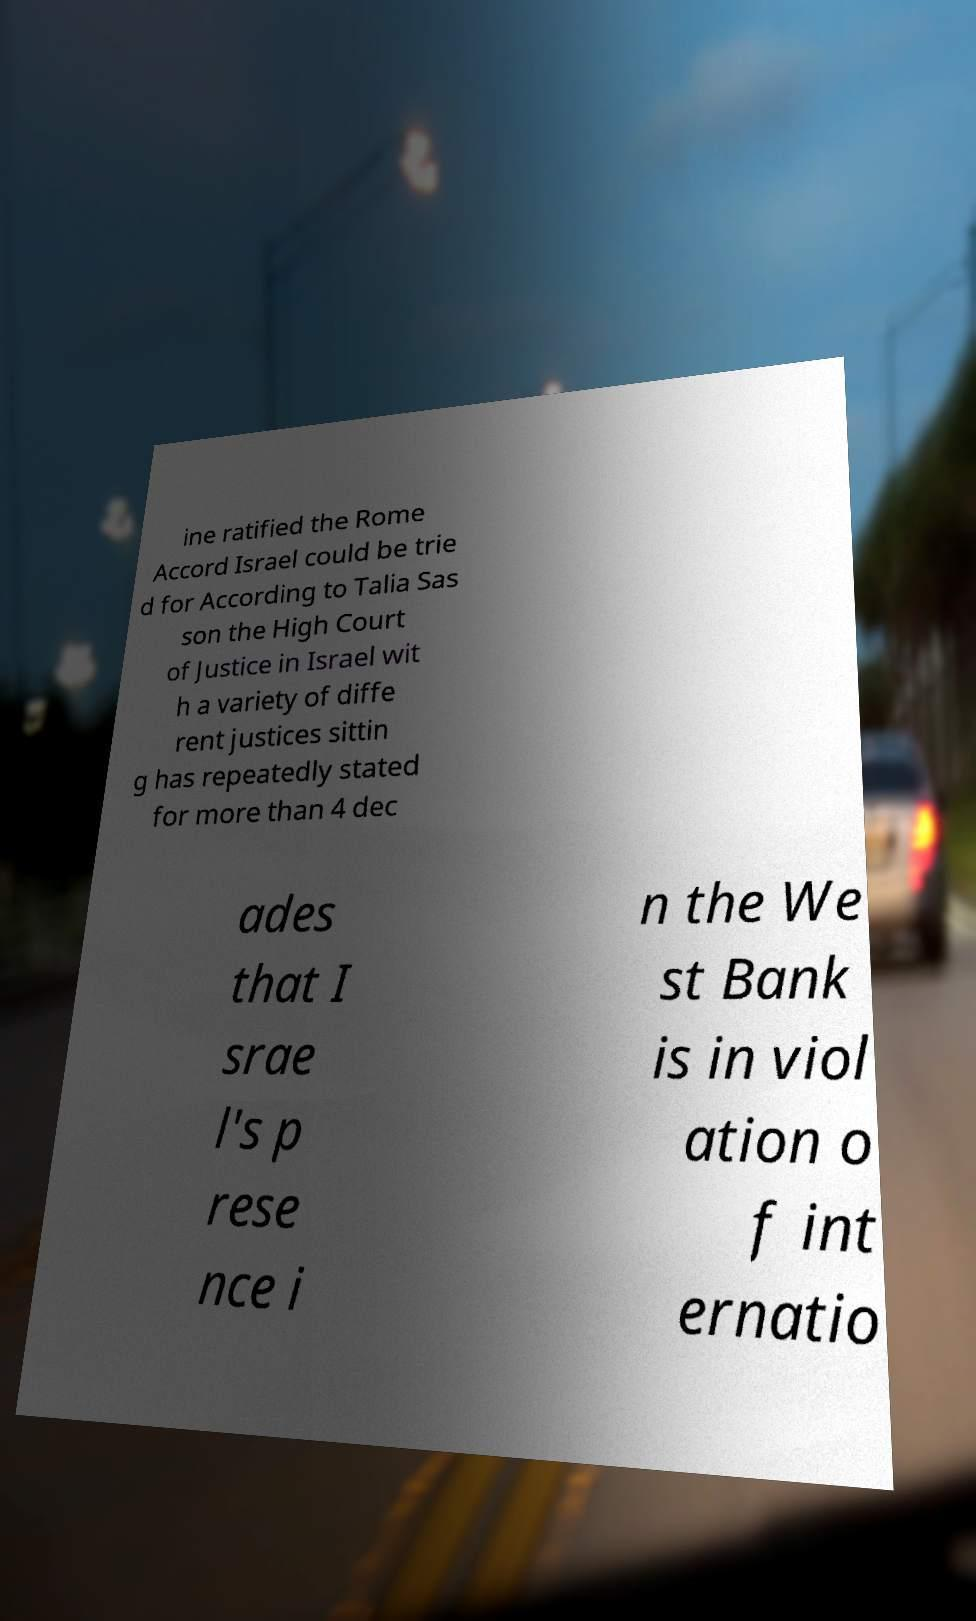Could you assist in decoding the text presented in this image and type it out clearly? ine ratified the Rome Accord Israel could be trie d for According to Talia Sas son the High Court of Justice in Israel wit h a variety of diffe rent justices sittin g has repeatedly stated for more than 4 dec ades that I srae l's p rese nce i n the We st Bank is in viol ation o f int ernatio 